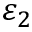<formula> <loc_0><loc_0><loc_500><loc_500>\varepsilon _ { 2 }</formula> 